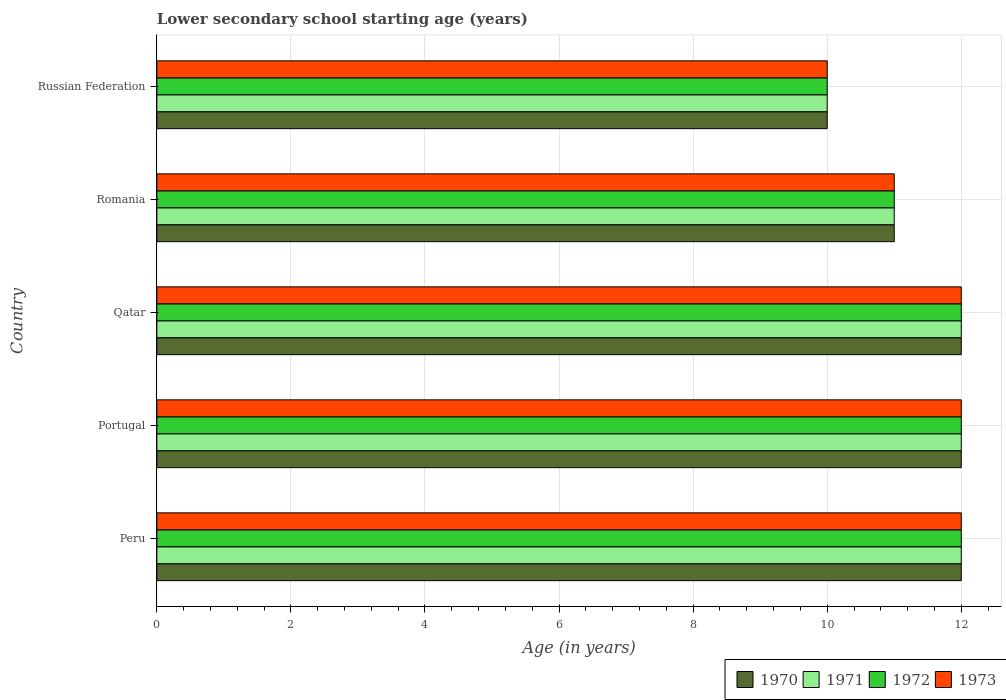What is the label of the 1st group of bars from the top?
Your answer should be compact. Russian Federation. Across all countries, what is the minimum lower secondary school starting age of children in 1970?
Keep it short and to the point. 10. In which country was the lower secondary school starting age of children in 1972 maximum?
Offer a very short reply. Peru. In which country was the lower secondary school starting age of children in 1973 minimum?
Keep it short and to the point. Russian Federation. What is the total lower secondary school starting age of children in 1970 in the graph?
Your response must be concise. 57. What is the difference between the lower secondary school starting age of children in 1972 in Portugal and that in Russian Federation?
Give a very brief answer. 2. What is the difference between the lower secondary school starting age of children in 1971 in Romania and the lower secondary school starting age of children in 1970 in Peru?
Ensure brevity in your answer.  -1. What is the average lower secondary school starting age of children in 1970 per country?
Your answer should be very brief. 11.4. What is the difference between the lower secondary school starting age of children in 1973 and lower secondary school starting age of children in 1972 in Peru?
Make the answer very short. 0. What is the ratio of the lower secondary school starting age of children in 1971 in Portugal to that in Romania?
Give a very brief answer. 1.09. Is the lower secondary school starting age of children in 1973 in Peru less than that in Russian Federation?
Give a very brief answer. No. Is the difference between the lower secondary school starting age of children in 1973 in Romania and Russian Federation greater than the difference between the lower secondary school starting age of children in 1972 in Romania and Russian Federation?
Your answer should be very brief. No. Is the sum of the lower secondary school starting age of children in 1972 in Peru and Qatar greater than the maximum lower secondary school starting age of children in 1971 across all countries?
Provide a succinct answer. Yes. Is it the case that in every country, the sum of the lower secondary school starting age of children in 1973 and lower secondary school starting age of children in 1971 is greater than the sum of lower secondary school starting age of children in 1970 and lower secondary school starting age of children in 1972?
Offer a very short reply. No. What does the 3rd bar from the top in Portugal represents?
Provide a succinct answer. 1971. How many bars are there?
Provide a short and direct response. 20. Are all the bars in the graph horizontal?
Ensure brevity in your answer.  Yes. Are the values on the major ticks of X-axis written in scientific E-notation?
Your answer should be compact. No. Does the graph contain any zero values?
Offer a terse response. No. Where does the legend appear in the graph?
Provide a short and direct response. Bottom right. How many legend labels are there?
Keep it short and to the point. 4. What is the title of the graph?
Provide a succinct answer. Lower secondary school starting age (years). What is the label or title of the X-axis?
Ensure brevity in your answer.  Age (in years). What is the label or title of the Y-axis?
Make the answer very short. Country. What is the Age (in years) in 1970 in Peru?
Give a very brief answer. 12. What is the Age (in years) of 1972 in Peru?
Ensure brevity in your answer.  12. What is the Age (in years) in 1970 in Portugal?
Give a very brief answer. 12. What is the Age (in years) in 1971 in Portugal?
Your answer should be compact. 12. What is the Age (in years) in 1972 in Portugal?
Provide a succinct answer. 12. What is the Age (in years) in 1970 in Qatar?
Your answer should be compact. 12. What is the Age (in years) in 1970 in Romania?
Keep it short and to the point. 11. What is the Age (in years) of 1970 in Russian Federation?
Make the answer very short. 10. Across all countries, what is the maximum Age (in years) in 1970?
Offer a very short reply. 12. Across all countries, what is the maximum Age (in years) in 1972?
Keep it short and to the point. 12. Across all countries, what is the maximum Age (in years) in 1973?
Your answer should be compact. 12. Across all countries, what is the minimum Age (in years) of 1972?
Make the answer very short. 10. What is the total Age (in years) in 1971 in the graph?
Offer a terse response. 57. What is the total Age (in years) in 1973 in the graph?
Offer a terse response. 57. What is the difference between the Age (in years) in 1970 in Peru and that in Portugal?
Offer a very short reply. 0. What is the difference between the Age (in years) of 1971 in Peru and that in Portugal?
Ensure brevity in your answer.  0. What is the difference between the Age (in years) in 1972 in Peru and that in Portugal?
Your answer should be very brief. 0. What is the difference between the Age (in years) in 1973 in Peru and that in Portugal?
Your answer should be compact. 0. What is the difference between the Age (in years) in 1971 in Peru and that in Qatar?
Your response must be concise. 0. What is the difference between the Age (in years) of 1970 in Peru and that in Romania?
Your response must be concise. 1. What is the difference between the Age (in years) in 1972 in Peru and that in Romania?
Make the answer very short. 1. What is the difference between the Age (in years) in 1970 in Peru and that in Russian Federation?
Provide a short and direct response. 2. What is the difference between the Age (in years) in 1972 in Peru and that in Russian Federation?
Provide a succinct answer. 2. What is the difference between the Age (in years) in 1970 in Portugal and that in Qatar?
Make the answer very short. 0. What is the difference between the Age (in years) in 1970 in Portugal and that in Romania?
Offer a terse response. 1. What is the difference between the Age (in years) in 1971 in Portugal and that in Romania?
Your answer should be compact. 1. What is the difference between the Age (in years) in 1970 in Portugal and that in Russian Federation?
Ensure brevity in your answer.  2. What is the difference between the Age (in years) of 1971 in Portugal and that in Russian Federation?
Provide a succinct answer. 2. What is the difference between the Age (in years) of 1972 in Portugal and that in Russian Federation?
Your response must be concise. 2. What is the difference between the Age (in years) in 1971 in Qatar and that in Romania?
Your answer should be compact. 1. What is the difference between the Age (in years) of 1972 in Qatar and that in Romania?
Your answer should be compact. 1. What is the difference between the Age (in years) in 1973 in Qatar and that in Romania?
Ensure brevity in your answer.  1. What is the difference between the Age (in years) in 1971 in Qatar and that in Russian Federation?
Offer a very short reply. 2. What is the difference between the Age (in years) in 1972 in Qatar and that in Russian Federation?
Provide a succinct answer. 2. What is the difference between the Age (in years) in 1971 in Romania and that in Russian Federation?
Provide a short and direct response. 1. What is the difference between the Age (in years) in 1970 in Peru and the Age (in years) in 1971 in Portugal?
Offer a terse response. 0. What is the difference between the Age (in years) in 1970 in Peru and the Age (in years) in 1973 in Portugal?
Offer a very short reply. 0. What is the difference between the Age (in years) of 1971 in Peru and the Age (in years) of 1972 in Portugal?
Ensure brevity in your answer.  0. What is the difference between the Age (in years) in 1971 in Peru and the Age (in years) in 1973 in Portugal?
Ensure brevity in your answer.  0. What is the difference between the Age (in years) of 1970 in Peru and the Age (in years) of 1972 in Qatar?
Give a very brief answer. 0. What is the difference between the Age (in years) of 1970 in Peru and the Age (in years) of 1973 in Qatar?
Your response must be concise. 0. What is the difference between the Age (in years) of 1972 in Peru and the Age (in years) of 1973 in Qatar?
Your answer should be compact. 0. What is the difference between the Age (in years) in 1972 in Peru and the Age (in years) in 1973 in Romania?
Give a very brief answer. 1. What is the difference between the Age (in years) of 1970 in Peru and the Age (in years) of 1972 in Russian Federation?
Ensure brevity in your answer.  2. What is the difference between the Age (in years) in 1970 in Peru and the Age (in years) in 1973 in Russian Federation?
Give a very brief answer. 2. What is the difference between the Age (in years) of 1971 in Peru and the Age (in years) of 1972 in Russian Federation?
Your response must be concise. 2. What is the difference between the Age (in years) in 1970 in Portugal and the Age (in years) in 1972 in Qatar?
Your answer should be very brief. 0. What is the difference between the Age (in years) in 1971 in Portugal and the Age (in years) in 1972 in Qatar?
Your answer should be very brief. 0. What is the difference between the Age (in years) of 1971 in Portugal and the Age (in years) of 1973 in Qatar?
Provide a succinct answer. 0. What is the difference between the Age (in years) in 1972 in Portugal and the Age (in years) in 1973 in Qatar?
Ensure brevity in your answer.  0. What is the difference between the Age (in years) of 1970 in Portugal and the Age (in years) of 1971 in Romania?
Provide a short and direct response. 1. What is the difference between the Age (in years) in 1970 in Portugal and the Age (in years) in 1972 in Romania?
Offer a terse response. 1. What is the difference between the Age (in years) of 1971 in Portugal and the Age (in years) of 1972 in Romania?
Keep it short and to the point. 1. What is the difference between the Age (in years) of 1971 in Portugal and the Age (in years) of 1973 in Romania?
Your response must be concise. 1. What is the difference between the Age (in years) of 1970 in Portugal and the Age (in years) of 1971 in Russian Federation?
Your answer should be compact. 2. What is the difference between the Age (in years) of 1970 in Portugal and the Age (in years) of 1972 in Russian Federation?
Your answer should be very brief. 2. What is the difference between the Age (in years) of 1970 in Portugal and the Age (in years) of 1973 in Russian Federation?
Your answer should be very brief. 2. What is the difference between the Age (in years) in 1971 in Portugal and the Age (in years) in 1972 in Russian Federation?
Provide a short and direct response. 2. What is the difference between the Age (in years) of 1971 in Portugal and the Age (in years) of 1973 in Russian Federation?
Keep it short and to the point. 2. What is the difference between the Age (in years) of 1972 in Portugal and the Age (in years) of 1973 in Russian Federation?
Provide a short and direct response. 2. What is the difference between the Age (in years) in 1970 in Qatar and the Age (in years) in 1971 in Romania?
Offer a very short reply. 1. What is the difference between the Age (in years) of 1971 in Qatar and the Age (in years) of 1972 in Romania?
Offer a terse response. 1. What is the difference between the Age (in years) of 1971 in Qatar and the Age (in years) of 1973 in Romania?
Your response must be concise. 1. What is the difference between the Age (in years) in 1970 in Qatar and the Age (in years) in 1973 in Russian Federation?
Provide a succinct answer. 2. What is the difference between the Age (in years) in 1971 in Qatar and the Age (in years) in 1972 in Russian Federation?
Give a very brief answer. 2. What is the difference between the Age (in years) of 1971 in Qatar and the Age (in years) of 1973 in Russian Federation?
Offer a terse response. 2. What is the difference between the Age (in years) of 1972 in Qatar and the Age (in years) of 1973 in Russian Federation?
Ensure brevity in your answer.  2. What is the difference between the Age (in years) in 1971 in Romania and the Age (in years) in 1972 in Russian Federation?
Give a very brief answer. 1. What is the difference between the Age (in years) in 1972 in Romania and the Age (in years) in 1973 in Russian Federation?
Keep it short and to the point. 1. What is the average Age (in years) of 1970 per country?
Ensure brevity in your answer.  11.4. What is the average Age (in years) of 1973 per country?
Give a very brief answer. 11.4. What is the difference between the Age (in years) in 1970 and Age (in years) in 1971 in Peru?
Provide a succinct answer. 0. What is the difference between the Age (in years) in 1970 and Age (in years) in 1973 in Peru?
Offer a terse response. 0. What is the difference between the Age (in years) of 1971 and Age (in years) of 1973 in Peru?
Give a very brief answer. 0. What is the difference between the Age (in years) in 1972 and Age (in years) in 1973 in Peru?
Provide a short and direct response. 0. What is the difference between the Age (in years) of 1970 and Age (in years) of 1973 in Portugal?
Your answer should be compact. 0. What is the difference between the Age (in years) in 1971 and Age (in years) in 1972 in Portugal?
Give a very brief answer. 0. What is the difference between the Age (in years) in 1971 and Age (in years) in 1972 in Qatar?
Provide a succinct answer. 0. What is the difference between the Age (in years) of 1972 and Age (in years) of 1973 in Qatar?
Provide a succinct answer. 0. What is the difference between the Age (in years) in 1970 and Age (in years) in 1971 in Romania?
Ensure brevity in your answer.  0. What is the difference between the Age (in years) in 1970 and Age (in years) in 1972 in Romania?
Your answer should be very brief. 0. What is the difference between the Age (in years) of 1970 and Age (in years) of 1973 in Romania?
Keep it short and to the point. 0. What is the difference between the Age (in years) in 1971 and Age (in years) in 1972 in Romania?
Offer a very short reply. 0. What is the difference between the Age (in years) of 1972 and Age (in years) of 1973 in Romania?
Keep it short and to the point. 0. What is the difference between the Age (in years) of 1970 and Age (in years) of 1971 in Russian Federation?
Your answer should be compact. 0. What is the difference between the Age (in years) in 1971 and Age (in years) in 1972 in Russian Federation?
Make the answer very short. 0. What is the difference between the Age (in years) in 1972 and Age (in years) in 1973 in Russian Federation?
Keep it short and to the point. 0. What is the ratio of the Age (in years) in 1970 in Peru to that in Portugal?
Give a very brief answer. 1. What is the ratio of the Age (in years) of 1972 in Peru to that in Portugal?
Give a very brief answer. 1. What is the ratio of the Age (in years) of 1973 in Peru to that in Portugal?
Your answer should be compact. 1. What is the ratio of the Age (in years) of 1971 in Peru to that in Qatar?
Your answer should be compact. 1. What is the ratio of the Age (in years) in 1971 in Peru to that in Romania?
Keep it short and to the point. 1.09. What is the ratio of the Age (in years) in 1972 in Peru to that in Romania?
Provide a succinct answer. 1.09. What is the ratio of the Age (in years) in 1971 in Peru to that in Russian Federation?
Give a very brief answer. 1.2. What is the ratio of the Age (in years) of 1972 in Peru to that in Russian Federation?
Your answer should be very brief. 1.2. What is the ratio of the Age (in years) of 1973 in Peru to that in Russian Federation?
Provide a succinct answer. 1.2. What is the ratio of the Age (in years) of 1972 in Portugal to that in Qatar?
Make the answer very short. 1. What is the ratio of the Age (in years) of 1973 in Portugal to that in Qatar?
Provide a short and direct response. 1. What is the ratio of the Age (in years) of 1973 in Portugal to that in Romania?
Offer a very short reply. 1.09. What is the ratio of the Age (in years) of 1970 in Portugal to that in Russian Federation?
Provide a succinct answer. 1.2. What is the ratio of the Age (in years) in 1971 in Qatar to that in Romania?
Provide a short and direct response. 1.09. What is the ratio of the Age (in years) of 1972 in Qatar to that in Romania?
Offer a terse response. 1.09. What is the ratio of the Age (in years) in 1971 in Qatar to that in Russian Federation?
Provide a short and direct response. 1.2. What is the ratio of the Age (in years) in 1973 in Qatar to that in Russian Federation?
Ensure brevity in your answer.  1.2. What is the ratio of the Age (in years) of 1971 in Romania to that in Russian Federation?
Provide a short and direct response. 1.1. What is the ratio of the Age (in years) in 1972 in Romania to that in Russian Federation?
Offer a terse response. 1.1. What is the difference between the highest and the second highest Age (in years) of 1970?
Offer a very short reply. 0. What is the difference between the highest and the second highest Age (in years) of 1973?
Provide a short and direct response. 0. What is the difference between the highest and the lowest Age (in years) in 1971?
Offer a very short reply. 2. What is the difference between the highest and the lowest Age (in years) in 1972?
Offer a terse response. 2. 